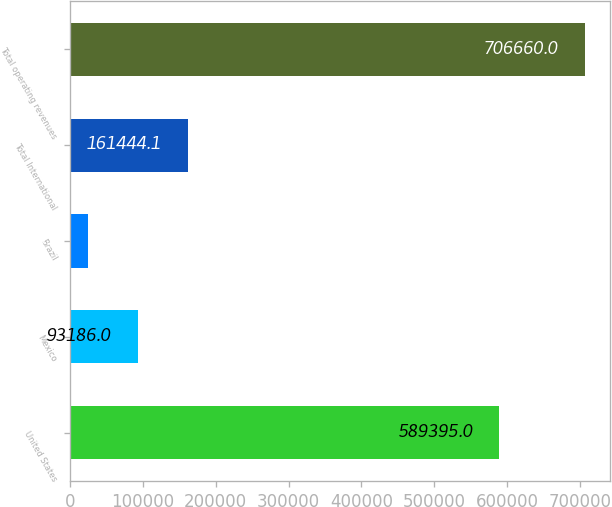<chart> <loc_0><loc_0><loc_500><loc_500><bar_chart><fcel>United States<fcel>Mexico<fcel>Brazil<fcel>Total International<fcel>Total operating revenues<nl><fcel>589395<fcel>93186<fcel>24079<fcel>161444<fcel>706660<nl></chart> 